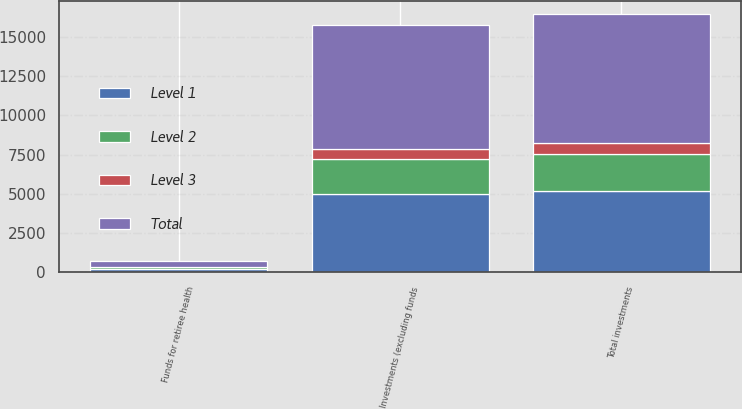Convert chart to OTSL. <chart><loc_0><loc_0><loc_500><loc_500><stacked_bar_chart><ecel><fcel>Total investments<fcel>Funds for retiree health<fcel>Investments (excluding funds<nl><fcel>Level 1<fcel>5187<fcel>226<fcel>4961<nl><fcel>Level 2<fcel>2368<fcel>103<fcel>2265<nl><fcel>Level 3<fcel>680<fcel>30<fcel>650<nl><fcel>Total<fcel>8235<fcel>359<fcel>7876<nl></chart> 